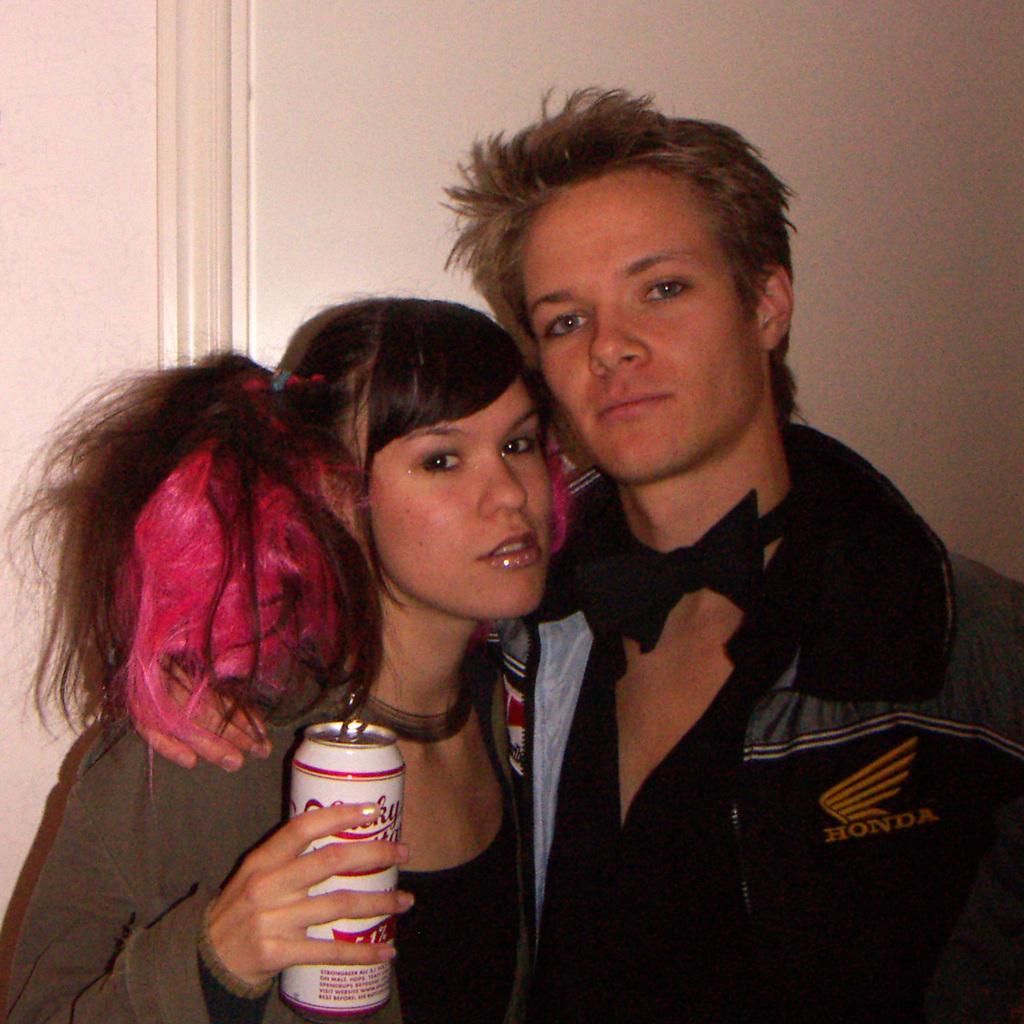Please provide a concise description of this image. In this image we can see a man and a woman. In that a woman is holding a tin. On the backside we can see a wall. 